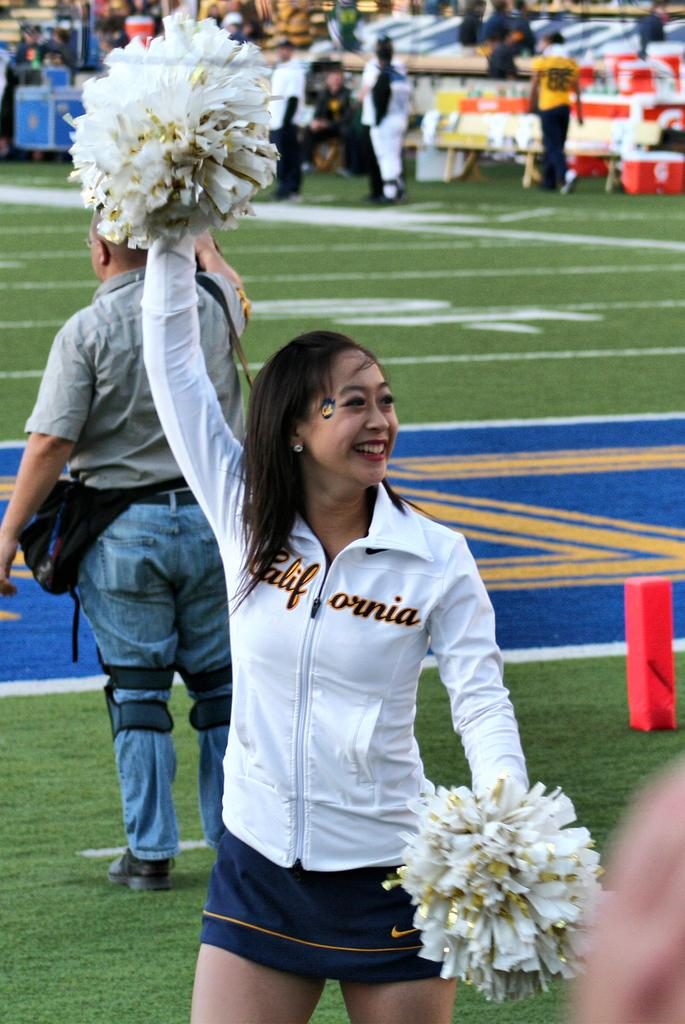How many people are in the image? There are people in the image, but the exact number is not specified. What is the lady holding in her hands? The lady is holding objects in her hands, but their nature is not described. What type of objects can be seen in the image? There are boxes in the image. What type of furniture is present in the image? There are benches in the image. What is on the ground in the image? There is an object on the ground in the image. What type of vegetable is being served for lunch on the dock in the image? There is no dock, lunch, or vegetable present in the image. 